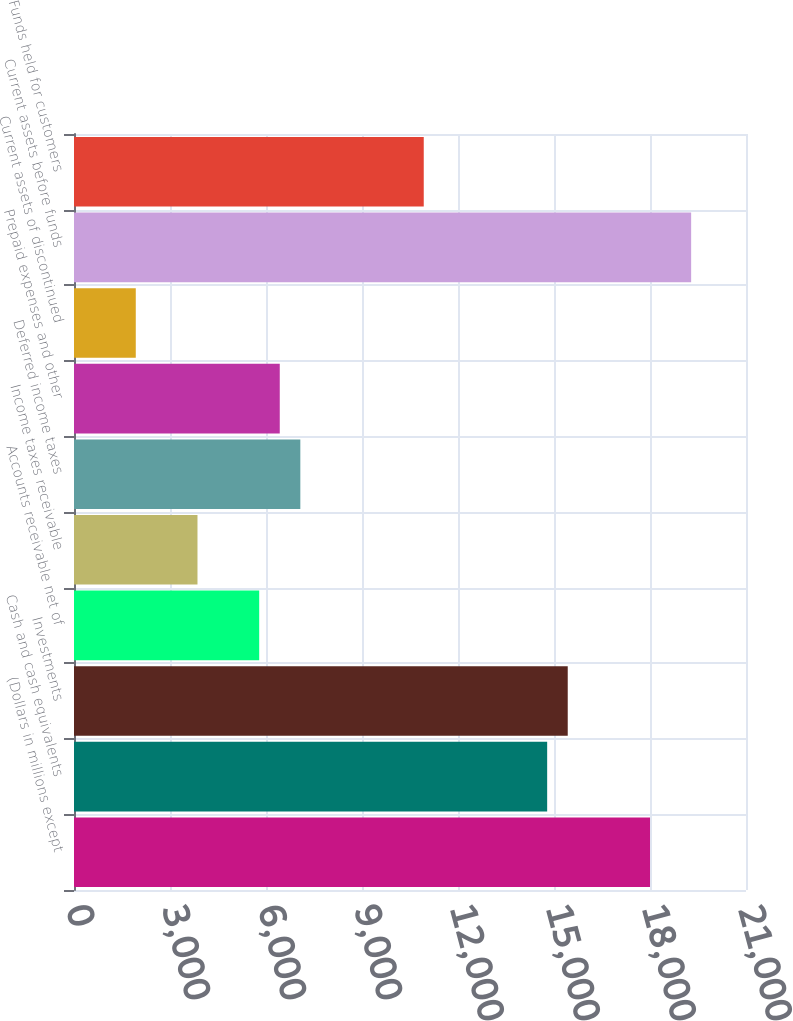<chart> <loc_0><loc_0><loc_500><loc_500><bar_chart><fcel>(Dollars in millions except<fcel>Cash and cash equivalents<fcel>Investments<fcel>Accounts receivable net of<fcel>Income taxes receivable<fcel>Deferred income taxes<fcel>Prepaid expenses and other<fcel>Current assets of discontinued<fcel>Current assets before funds<fcel>Funds held for customers<nl><fcel>18000.4<fcel>14786.4<fcel>15429.2<fcel>5787.2<fcel>3858.8<fcel>7072.8<fcel>6430<fcel>1930.4<fcel>19286<fcel>10929.6<nl></chart> 